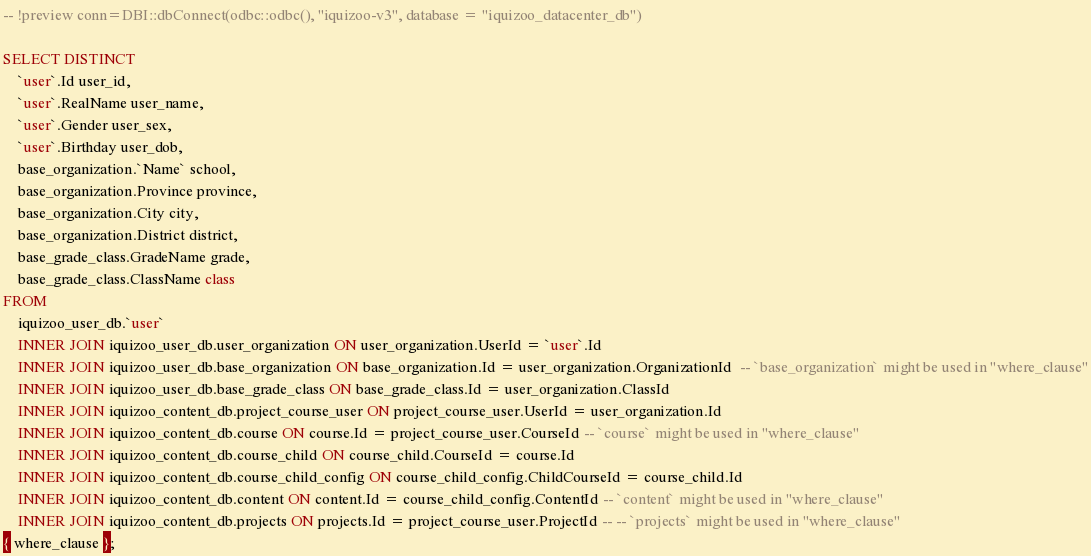<code> <loc_0><loc_0><loc_500><loc_500><_SQL_>-- !preview conn=DBI::dbConnect(odbc::odbc(), "iquizoo-v3", database = "iquizoo_datacenter_db")

SELECT DISTINCT
	`user`.Id user_id,
	`user`.RealName user_name,
	`user`.Gender user_sex,
	`user`.Birthday user_dob,
	base_organization.`Name` school,
	base_organization.Province province,
	base_organization.City city,
	base_organization.District district,
	base_grade_class.GradeName grade,
	base_grade_class.ClassName class
FROM
	iquizoo_user_db.`user`
	INNER JOIN iquizoo_user_db.user_organization ON user_organization.UserId = `user`.Id
	INNER JOIN iquizoo_user_db.base_organization ON base_organization.Id = user_organization.OrganizationId  -- `base_organization` might be used in "where_clause"
	INNER JOIN iquizoo_user_db.base_grade_class ON base_grade_class.Id = user_organization.ClassId
	INNER JOIN iquizoo_content_db.project_course_user ON project_course_user.UserId = user_organization.Id
	INNER JOIN iquizoo_content_db.course ON course.Id = project_course_user.CourseId -- `course` might be used in "where_clause"
	INNER JOIN iquizoo_content_db.course_child ON course_child.CourseId = course.Id
	INNER JOIN iquizoo_content_db.course_child_config ON course_child_config.ChildCourseId = course_child.Id
	INNER JOIN iquizoo_content_db.content ON content.Id = course_child_config.ContentId -- `content` might be used in "where_clause"
	INNER JOIN iquizoo_content_db.projects ON projects.Id = project_course_user.ProjectId -- -- `projects` might be used in "where_clause"
{ where_clause };
</code> 